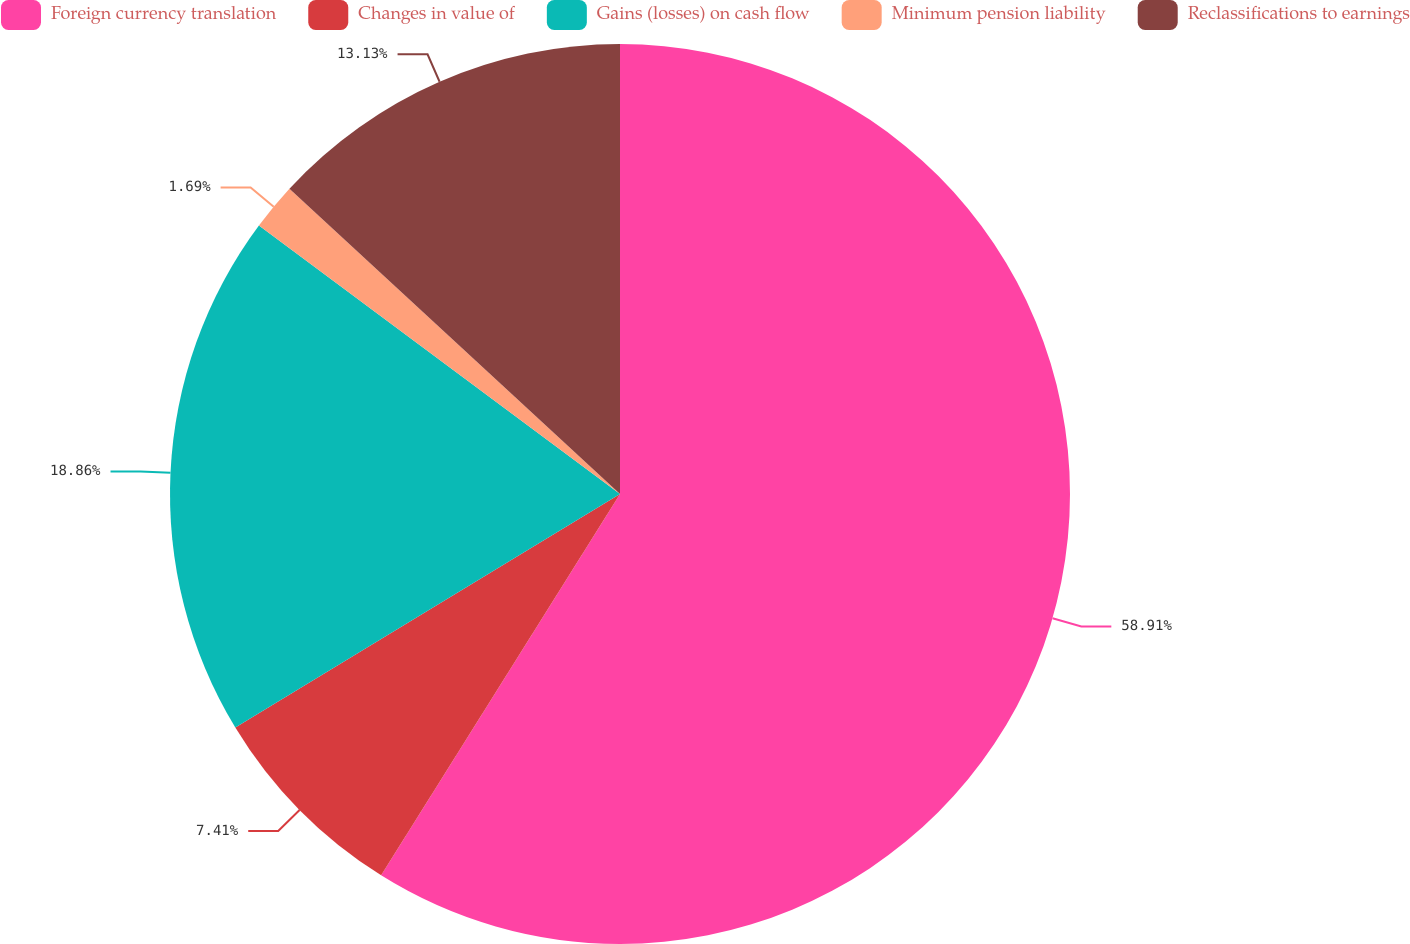Convert chart. <chart><loc_0><loc_0><loc_500><loc_500><pie_chart><fcel>Foreign currency translation<fcel>Changes in value of<fcel>Gains (losses) on cash flow<fcel>Minimum pension liability<fcel>Reclassifications to earnings<nl><fcel>58.9%<fcel>7.41%<fcel>18.86%<fcel>1.69%<fcel>13.13%<nl></chart> 